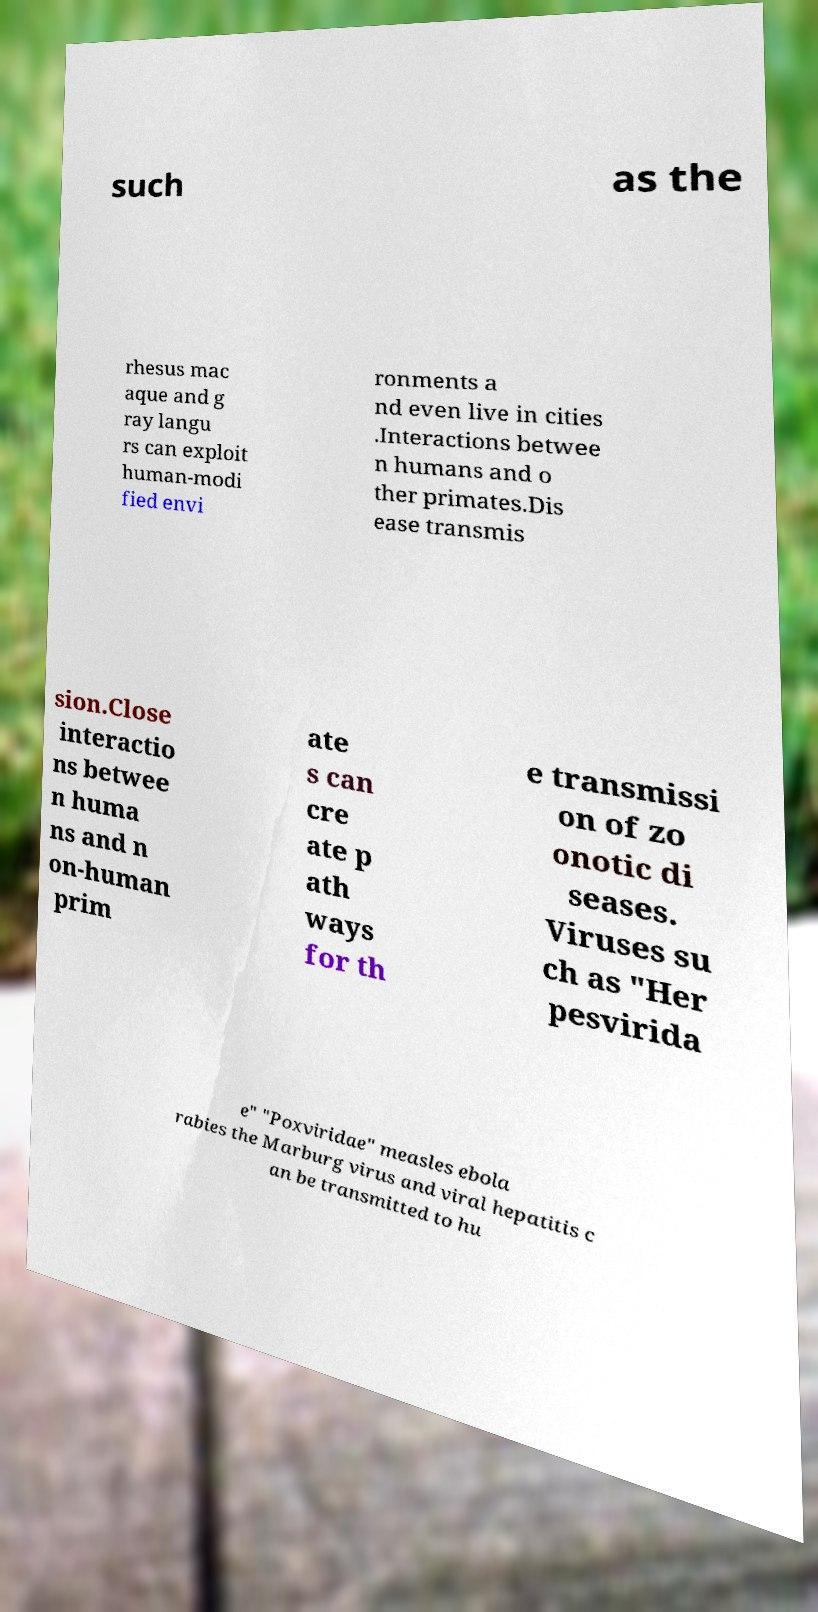I need the written content from this picture converted into text. Can you do that? such as the rhesus mac aque and g ray langu rs can exploit human-modi fied envi ronments a nd even live in cities .Interactions betwee n humans and o ther primates.Dis ease transmis sion.Close interactio ns betwee n huma ns and n on-human prim ate s can cre ate p ath ways for th e transmissi on of zo onotic di seases. Viruses su ch as "Her pesvirida e" "Poxviridae" measles ebola rabies the Marburg virus and viral hepatitis c an be transmitted to hu 